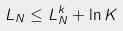Convert formula to latex. <formula><loc_0><loc_0><loc_500><loc_500>L _ { N } \leq L _ { N } ^ { k } + \ln K</formula> 